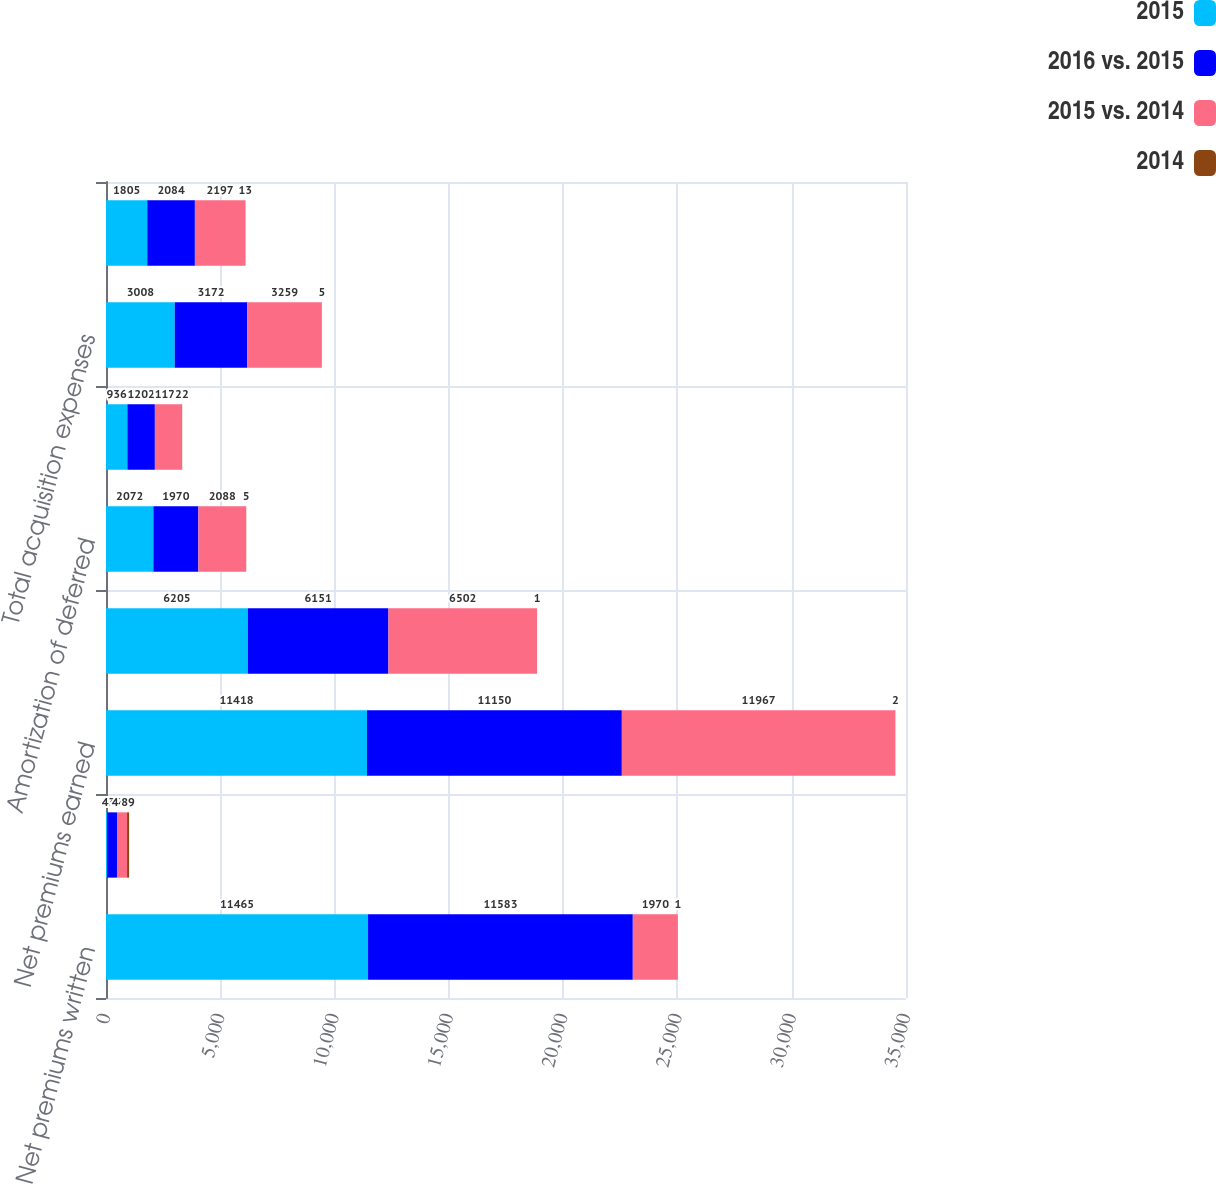Convert chart. <chart><loc_0><loc_0><loc_500><loc_500><stacked_bar_chart><ecel><fcel>Net premiums written<fcel>Increase in unearned premiums<fcel>Net premiums earned<fcel>Losses and loss adjustment<fcel>Amortization of deferred<fcel>t Other acquisition expenses<fcel>Total acquisition expenses<fcel>General operating expenses<nl><fcel>2015<fcel>11465<fcel>47<fcel>11418<fcel>6205<fcel>2072<fcel>936<fcel>3008<fcel>1805<nl><fcel>2016 vs. 2015<fcel>11583<fcel>433<fcel>11150<fcel>6151<fcel>1970<fcel>1202<fcel>3172<fcel>2084<nl><fcel>2015 vs. 2014<fcel>1970<fcel>441<fcel>11967<fcel>6502<fcel>2088<fcel>1171<fcel>3259<fcel>2197<nl><fcel>2014<fcel>1<fcel>89<fcel>2<fcel>1<fcel>5<fcel>22<fcel>5<fcel>13<nl></chart> 